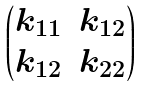<formula> <loc_0><loc_0><loc_500><loc_500>\begin{pmatrix} k _ { 1 1 } & k _ { 1 2 } \\ k _ { 1 2 } & k _ { 2 2 } \end{pmatrix}</formula> 